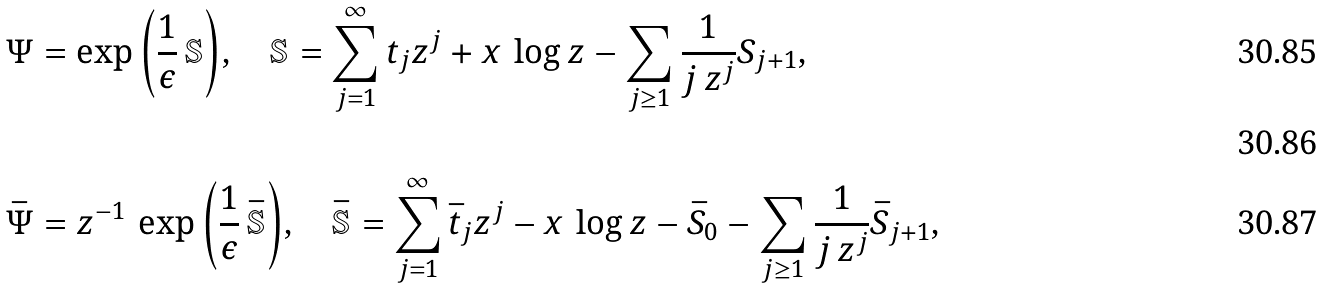Convert formula to latex. <formula><loc_0><loc_0><loc_500><loc_500>& \Psi = \exp { \left ( \frac { 1 } { \epsilon } \, \mathbb { S } \right ) } , \quad \mathbb { S } = \sum _ { j = 1 } ^ { \infty } t _ { j } z ^ { j } + x \, \log { z } - \sum _ { j \geq 1 } \frac { 1 } { j \, z ^ { j } } S _ { j + 1 } , \\ \\ \ & \bar { \Psi } = z ^ { - 1 } \, \exp { \left ( \frac { 1 } { \epsilon } \, \bar { \mathbb { S } } \right ) } , \quad \bar { \mathbb { S } } = \sum _ { j = 1 } ^ { \infty } \bar { t } _ { j } z ^ { j } - x \, \log { z } - \bar { S } _ { 0 } - \sum _ { j \geq 1 } \frac { 1 } { j \, z ^ { j } } \bar { S } _ { j + 1 } ,</formula> 